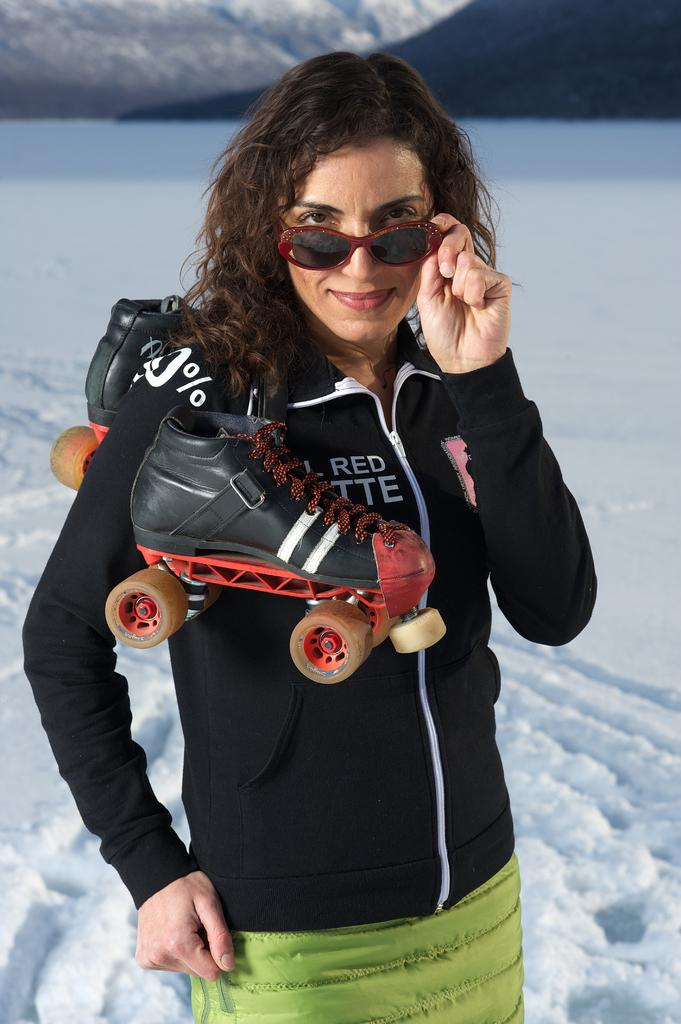Who is present in the image? There is a woman in the image. What is the condition of the ground in the image? The ground is covered with snow. What is the woman doing in the image? The woman is standing on the ground. What items is the woman carrying in the image? The woman is carrying roller skates on her shoulder and holding sunglasses. What type of vegetable is being pulled by the yoke in the image? There is no yoke or vegetable present in the image. 